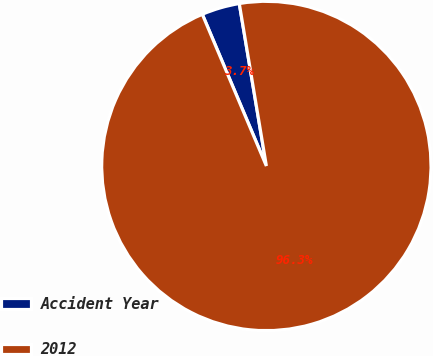<chart> <loc_0><loc_0><loc_500><loc_500><pie_chart><fcel>Accident Year<fcel>2012<nl><fcel>3.73%<fcel>96.27%<nl></chart> 